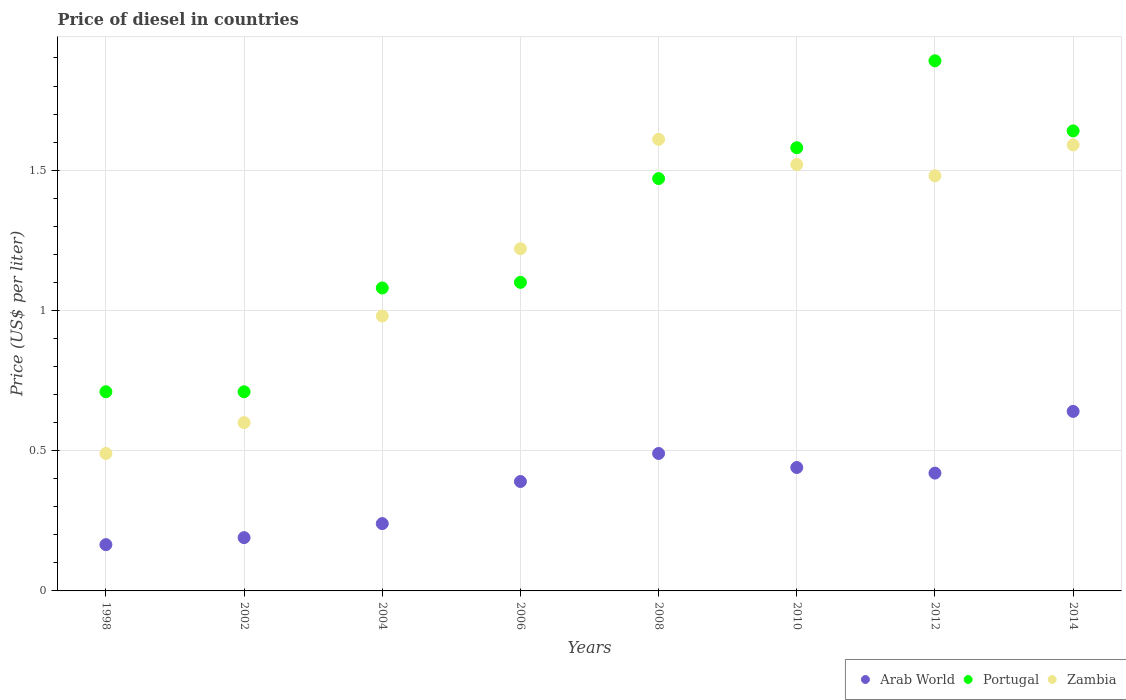What is the price of diesel in Zambia in 2012?
Your response must be concise. 1.48. Across all years, what is the maximum price of diesel in Zambia?
Offer a terse response. 1.61. Across all years, what is the minimum price of diesel in Portugal?
Provide a short and direct response. 0.71. What is the total price of diesel in Portugal in the graph?
Keep it short and to the point. 10.18. What is the difference between the price of diesel in Portugal in 2010 and that in 2014?
Provide a succinct answer. -0.06. What is the difference between the price of diesel in Portugal in 2014 and the price of diesel in Arab World in 2012?
Offer a very short reply. 1.22. What is the average price of diesel in Arab World per year?
Keep it short and to the point. 0.37. In the year 2006, what is the difference between the price of diesel in Arab World and price of diesel in Portugal?
Your response must be concise. -0.71. In how many years, is the price of diesel in Arab World greater than 0.1 US$?
Offer a terse response. 8. What is the ratio of the price of diesel in Portugal in 2012 to that in 2014?
Offer a terse response. 1.15. Is the difference between the price of diesel in Arab World in 2010 and 2012 greater than the difference between the price of diesel in Portugal in 2010 and 2012?
Offer a very short reply. Yes. What is the difference between the highest and the second highest price of diesel in Zambia?
Give a very brief answer. 0.02. What is the difference between the highest and the lowest price of diesel in Zambia?
Your response must be concise. 1.12. Does the price of diesel in Portugal monotonically increase over the years?
Your response must be concise. No. How many years are there in the graph?
Your response must be concise. 8. What is the difference between two consecutive major ticks on the Y-axis?
Ensure brevity in your answer.  0.5. Are the values on the major ticks of Y-axis written in scientific E-notation?
Make the answer very short. No. Does the graph contain grids?
Offer a terse response. Yes. Where does the legend appear in the graph?
Offer a terse response. Bottom right. How many legend labels are there?
Offer a very short reply. 3. How are the legend labels stacked?
Ensure brevity in your answer.  Horizontal. What is the title of the graph?
Provide a short and direct response. Price of diesel in countries. What is the label or title of the Y-axis?
Make the answer very short. Price (US$ per liter). What is the Price (US$ per liter) of Arab World in 1998?
Offer a very short reply. 0.17. What is the Price (US$ per liter) of Portugal in 1998?
Offer a very short reply. 0.71. What is the Price (US$ per liter) in Zambia in 1998?
Your answer should be very brief. 0.49. What is the Price (US$ per liter) in Arab World in 2002?
Your answer should be very brief. 0.19. What is the Price (US$ per liter) of Portugal in 2002?
Offer a very short reply. 0.71. What is the Price (US$ per liter) of Zambia in 2002?
Your answer should be compact. 0.6. What is the Price (US$ per liter) in Arab World in 2004?
Provide a short and direct response. 0.24. What is the Price (US$ per liter) in Portugal in 2004?
Your answer should be compact. 1.08. What is the Price (US$ per liter) in Zambia in 2004?
Provide a succinct answer. 0.98. What is the Price (US$ per liter) of Arab World in 2006?
Your answer should be compact. 0.39. What is the Price (US$ per liter) of Zambia in 2006?
Ensure brevity in your answer.  1.22. What is the Price (US$ per liter) in Arab World in 2008?
Your answer should be compact. 0.49. What is the Price (US$ per liter) in Portugal in 2008?
Ensure brevity in your answer.  1.47. What is the Price (US$ per liter) in Zambia in 2008?
Offer a very short reply. 1.61. What is the Price (US$ per liter) in Arab World in 2010?
Offer a terse response. 0.44. What is the Price (US$ per liter) of Portugal in 2010?
Make the answer very short. 1.58. What is the Price (US$ per liter) in Zambia in 2010?
Make the answer very short. 1.52. What is the Price (US$ per liter) in Arab World in 2012?
Ensure brevity in your answer.  0.42. What is the Price (US$ per liter) in Portugal in 2012?
Offer a terse response. 1.89. What is the Price (US$ per liter) in Zambia in 2012?
Your answer should be compact. 1.48. What is the Price (US$ per liter) in Arab World in 2014?
Make the answer very short. 0.64. What is the Price (US$ per liter) in Portugal in 2014?
Your response must be concise. 1.64. What is the Price (US$ per liter) in Zambia in 2014?
Make the answer very short. 1.59. Across all years, what is the maximum Price (US$ per liter) in Arab World?
Keep it short and to the point. 0.64. Across all years, what is the maximum Price (US$ per liter) of Portugal?
Offer a very short reply. 1.89. Across all years, what is the maximum Price (US$ per liter) in Zambia?
Your response must be concise. 1.61. Across all years, what is the minimum Price (US$ per liter) of Arab World?
Offer a terse response. 0.17. Across all years, what is the minimum Price (US$ per liter) in Portugal?
Your answer should be compact. 0.71. Across all years, what is the minimum Price (US$ per liter) in Zambia?
Provide a short and direct response. 0.49. What is the total Price (US$ per liter) of Arab World in the graph?
Ensure brevity in your answer.  2.98. What is the total Price (US$ per liter) of Portugal in the graph?
Provide a short and direct response. 10.18. What is the total Price (US$ per liter) in Zambia in the graph?
Ensure brevity in your answer.  9.49. What is the difference between the Price (US$ per liter) of Arab World in 1998 and that in 2002?
Your response must be concise. -0.03. What is the difference between the Price (US$ per liter) in Portugal in 1998 and that in 2002?
Keep it short and to the point. 0. What is the difference between the Price (US$ per liter) in Zambia in 1998 and that in 2002?
Your response must be concise. -0.11. What is the difference between the Price (US$ per liter) of Arab World in 1998 and that in 2004?
Your answer should be very brief. -0.07. What is the difference between the Price (US$ per liter) of Portugal in 1998 and that in 2004?
Keep it short and to the point. -0.37. What is the difference between the Price (US$ per liter) of Zambia in 1998 and that in 2004?
Your answer should be very brief. -0.49. What is the difference between the Price (US$ per liter) in Arab World in 1998 and that in 2006?
Keep it short and to the point. -0.23. What is the difference between the Price (US$ per liter) in Portugal in 1998 and that in 2006?
Make the answer very short. -0.39. What is the difference between the Price (US$ per liter) in Zambia in 1998 and that in 2006?
Provide a short and direct response. -0.73. What is the difference between the Price (US$ per liter) in Arab World in 1998 and that in 2008?
Provide a short and direct response. -0.33. What is the difference between the Price (US$ per liter) in Portugal in 1998 and that in 2008?
Make the answer very short. -0.76. What is the difference between the Price (US$ per liter) of Zambia in 1998 and that in 2008?
Offer a very short reply. -1.12. What is the difference between the Price (US$ per liter) of Arab World in 1998 and that in 2010?
Your response must be concise. -0.28. What is the difference between the Price (US$ per liter) in Portugal in 1998 and that in 2010?
Provide a succinct answer. -0.87. What is the difference between the Price (US$ per liter) of Zambia in 1998 and that in 2010?
Provide a short and direct response. -1.03. What is the difference between the Price (US$ per liter) in Arab World in 1998 and that in 2012?
Provide a succinct answer. -0.26. What is the difference between the Price (US$ per liter) of Portugal in 1998 and that in 2012?
Your answer should be compact. -1.18. What is the difference between the Price (US$ per liter) in Zambia in 1998 and that in 2012?
Provide a succinct answer. -0.99. What is the difference between the Price (US$ per liter) of Arab World in 1998 and that in 2014?
Your answer should be very brief. -0.47. What is the difference between the Price (US$ per liter) of Portugal in 1998 and that in 2014?
Your answer should be very brief. -0.93. What is the difference between the Price (US$ per liter) of Zambia in 1998 and that in 2014?
Provide a short and direct response. -1.1. What is the difference between the Price (US$ per liter) of Arab World in 2002 and that in 2004?
Keep it short and to the point. -0.05. What is the difference between the Price (US$ per liter) of Portugal in 2002 and that in 2004?
Make the answer very short. -0.37. What is the difference between the Price (US$ per liter) in Zambia in 2002 and that in 2004?
Offer a very short reply. -0.38. What is the difference between the Price (US$ per liter) of Arab World in 2002 and that in 2006?
Your answer should be compact. -0.2. What is the difference between the Price (US$ per liter) of Portugal in 2002 and that in 2006?
Your answer should be compact. -0.39. What is the difference between the Price (US$ per liter) of Zambia in 2002 and that in 2006?
Provide a short and direct response. -0.62. What is the difference between the Price (US$ per liter) of Portugal in 2002 and that in 2008?
Make the answer very short. -0.76. What is the difference between the Price (US$ per liter) of Zambia in 2002 and that in 2008?
Ensure brevity in your answer.  -1.01. What is the difference between the Price (US$ per liter) in Arab World in 2002 and that in 2010?
Your answer should be compact. -0.25. What is the difference between the Price (US$ per liter) of Portugal in 2002 and that in 2010?
Your response must be concise. -0.87. What is the difference between the Price (US$ per liter) in Zambia in 2002 and that in 2010?
Give a very brief answer. -0.92. What is the difference between the Price (US$ per liter) in Arab World in 2002 and that in 2012?
Ensure brevity in your answer.  -0.23. What is the difference between the Price (US$ per liter) in Portugal in 2002 and that in 2012?
Make the answer very short. -1.18. What is the difference between the Price (US$ per liter) of Zambia in 2002 and that in 2012?
Ensure brevity in your answer.  -0.88. What is the difference between the Price (US$ per liter) in Arab World in 2002 and that in 2014?
Offer a terse response. -0.45. What is the difference between the Price (US$ per liter) of Portugal in 2002 and that in 2014?
Ensure brevity in your answer.  -0.93. What is the difference between the Price (US$ per liter) in Zambia in 2002 and that in 2014?
Your answer should be compact. -0.99. What is the difference between the Price (US$ per liter) in Arab World in 2004 and that in 2006?
Ensure brevity in your answer.  -0.15. What is the difference between the Price (US$ per liter) of Portugal in 2004 and that in 2006?
Provide a succinct answer. -0.02. What is the difference between the Price (US$ per liter) of Zambia in 2004 and that in 2006?
Offer a terse response. -0.24. What is the difference between the Price (US$ per liter) in Arab World in 2004 and that in 2008?
Offer a terse response. -0.25. What is the difference between the Price (US$ per liter) in Portugal in 2004 and that in 2008?
Offer a very short reply. -0.39. What is the difference between the Price (US$ per liter) in Zambia in 2004 and that in 2008?
Give a very brief answer. -0.63. What is the difference between the Price (US$ per liter) in Portugal in 2004 and that in 2010?
Give a very brief answer. -0.5. What is the difference between the Price (US$ per liter) of Zambia in 2004 and that in 2010?
Your answer should be compact. -0.54. What is the difference between the Price (US$ per liter) in Arab World in 2004 and that in 2012?
Provide a short and direct response. -0.18. What is the difference between the Price (US$ per liter) of Portugal in 2004 and that in 2012?
Offer a terse response. -0.81. What is the difference between the Price (US$ per liter) of Portugal in 2004 and that in 2014?
Your response must be concise. -0.56. What is the difference between the Price (US$ per liter) of Zambia in 2004 and that in 2014?
Make the answer very short. -0.61. What is the difference between the Price (US$ per liter) in Arab World in 2006 and that in 2008?
Offer a very short reply. -0.1. What is the difference between the Price (US$ per liter) of Portugal in 2006 and that in 2008?
Offer a very short reply. -0.37. What is the difference between the Price (US$ per liter) in Zambia in 2006 and that in 2008?
Keep it short and to the point. -0.39. What is the difference between the Price (US$ per liter) of Arab World in 2006 and that in 2010?
Your answer should be very brief. -0.05. What is the difference between the Price (US$ per liter) of Portugal in 2006 and that in 2010?
Your answer should be very brief. -0.48. What is the difference between the Price (US$ per liter) of Arab World in 2006 and that in 2012?
Keep it short and to the point. -0.03. What is the difference between the Price (US$ per liter) of Portugal in 2006 and that in 2012?
Give a very brief answer. -0.79. What is the difference between the Price (US$ per liter) of Zambia in 2006 and that in 2012?
Ensure brevity in your answer.  -0.26. What is the difference between the Price (US$ per liter) of Arab World in 2006 and that in 2014?
Provide a short and direct response. -0.25. What is the difference between the Price (US$ per liter) in Portugal in 2006 and that in 2014?
Offer a terse response. -0.54. What is the difference between the Price (US$ per liter) of Zambia in 2006 and that in 2014?
Ensure brevity in your answer.  -0.37. What is the difference between the Price (US$ per liter) of Portugal in 2008 and that in 2010?
Give a very brief answer. -0.11. What is the difference between the Price (US$ per liter) of Zambia in 2008 and that in 2010?
Your answer should be very brief. 0.09. What is the difference between the Price (US$ per liter) of Arab World in 2008 and that in 2012?
Offer a terse response. 0.07. What is the difference between the Price (US$ per liter) of Portugal in 2008 and that in 2012?
Give a very brief answer. -0.42. What is the difference between the Price (US$ per liter) in Zambia in 2008 and that in 2012?
Your answer should be very brief. 0.13. What is the difference between the Price (US$ per liter) in Portugal in 2008 and that in 2014?
Provide a succinct answer. -0.17. What is the difference between the Price (US$ per liter) of Zambia in 2008 and that in 2014?
Give a very brief answer. 0.02. What is the difference between the Price (US$ per liter) of Arab World in 2010 and that in 2012?
Offer a very short reply. 0.02. What is the difference between the Price (US$ per liter) in Portugal in 2010 and that in 2012?
Your answer should be compact. -0.31. What is the difference between the Price (US$ per liter) of Zambia in 2010 and that in 2012?
Offer a very short reply. 0.04. What is the difference between the Price (US$ per liter) in Arab World in 2010 and that in 2014?
Your answer should be very brief. -0.2. What is the difference between the Price (US$ per liter) in Portugal in 2010 and that in 2014?
Keep it short and to the point. -0.06. What is the difference between the Price (US$ per liter) of Zambia in 2010 and that in 2014?
Give a very brief answer. -0.07. What is the difference between the Price (US$ per liter) of Arab World in 2012 and that in 2014?
Make the answer very short. -0.22. What is the difference between the Price (US$ per liter) in Portugal in 2012 and that in 2014?
Ensure brevity in your answer.  0.25. What is the difference between the Price (US$ per liter) of Zambia in 2012 and that in 2014?
Ensure brevity in your answer.  -0.11. What is the difference between the Price (US$ per liter) in Arab World in 1998 and the Price (US$ per liter) in Portugal in 2002?
Make the answer very short. -0.55. What is the difference between the Price (US$ per liter) in Arab World in 1998 and the Price (US$ per liter) in Zambia in 2002?
Offer a very short reply. -0.43. What is the difference between the Price (US$ per liter) of Portugal in 1998 and the Price (US$ per liter) of Zambia in 2002?
Offer a terse response. 0.11. What is the difference between the Price (US$ per liter) in Arab World in 1998 and the Price (US$ per liter) in Portugal in 2004?
Offer a very short reply. -0.92. What is the difference between the Price (US$ per liter) in Arab World in 1998 and the Price (US$ per liter) in Zambia in 2004?
Provide a succinct answer. -0.81. What is the difference between the Price (US$ per liter) of Portugal in 1998 and the Price (US$ per liter) of Zambia in 2004?
Keep it short and to the point. -0.27. What is the difference between the Price (US$ per liter) of Arab World in 1998 and the Price (US$ per liter) of Portugal in 2006?
Offer a terse response. -0.94. What is the difference between the Price (US$ per liter) in Arab World in 1998 and the Price (US$ per liter) in Zambia in 2006?
Give a very brief answer. -1.05. What is the difference between the Price (US$ per liter) of Portugal in 1998 and the Price (US$ per liter) of Zambia in 2006?
Provide a short and direct response. -0.51. What is the difference between the Price (US$ per liter) of Arab World in 1998 and the Price (US$ per liter) of Portugal in 2008?
Keep it short and to the point. -1.3. What is the difference between the Price (US$ per liter) in Arab World in 1998 and the Price (US$ per liter) in Zambia in 2008?
Your answer should be very brief. -1.45. What is the difference between the Price (US$ per liter) in Portugal in 1998 and the Price (US$ per liter) in Zambia in 2008?
Offer a terse response. -0.9. What is the difference between the Price (US$ per liter) in Arab World in 1998 and the Price (US$ per liter) in Portugal in 2010?
Your response must be concise. -1.42. What is the difference between the Price (US$ per liter) of Arab World in 1998 and the Price (US$ per liter) of Zambia in 2010?
Offer a very short reply. -1.35. What is the difference between the Price (US$ per liter) in Portugal in 1998 and the Price (US$ per liter) in Zambia in 2010?
Give a very brief answer. -0.81. What is the difference between the Price (US$ per liter) of Arab World in 1998 and the Price (US$ per liter) of Portugal in 2012?
Ensure brevity in your answer.  -1.73. What is the difference between the Price (US$ per liter) in Arab World in 1998 and the Price (US$ per liter) in Zambia in 2012?
Provide a short and direct response. -1.31. What is the difference between the Price (US$ per liter) in Portugal in 1998 and the Price (US$ per liter) in Zambia in 2012?
Offer a terse response. -0.77. What is the difference between the Price (US$ per liter) in Arab World in 1998 and the Price (US$ per liter) in Portugal in 2014?
Your answer should be compact. -1.48. What is the difference between the Price (US$ per liter) in Arab World in 1998 and the Price (US$ per liter) in Zambia in 2014?
Offer a very short reply. -1.43. What is the difference between the Price (US$ per liter) of Portugal in 1998 and the Price (US$ per liter) of Zambia in 2014?
Make the answer very short. -0.88. What is the difference between the Price (US$ per liter) of Arab World in 2002 and the Price (US$ per liter) of Portugal in 2004?
Provide a succinct answer. -0.89. What is the difference between the Price (US$ per liter) in Arab World in 2002 and the Price (US$ per liter) in Zambia in 2004?
Give a very brief answer. -0.79. What is the difference between the Price (US$ per liter) of Portugal in 2002 and the Price (US$ per liter) of Zambia in 2004?
Make the answer very short. -0.27. What is the difference between the Price (US$ per liter) in Arab World in 2002 and the Price (US$ per liter) in Portugal in 2006?
Offer a terse response. -0.91. What is the difference between the Price (US$ per liter) of Arab World in 2002 and the Price (US$ per liter) of Zambia in 2006?
Keep it short and to the point. -1.03. What is the difference between the Price (US$ per liter) of Portugal in 2002 and the Price (US$ per liter) of Zambia in 2006?
Your answer should be compact. -0.51. What is the difference between the Price (US$ per liter) of Arab World in 2002 and the Price (US$ per liter) of Portugal in 2008?
Ensure brevity in your answer.  -1.28. What is the difference between the Price (US$ per liter) in Arab World in 2002 and the Price (US$ per liter) in Zambia in 2008?
Provide a succinct answer. -1.42. What is the difference between the Price (US$ per liter) in Portugal in 2002 and the Price (US$ per liter) in Zambia in 2008?
Give a very brief answer. -0.9. What is the difference between the Price (US$ per liter) in Arab World in 2002 and the Price (US$ per liter) in Portugal in 2010?
Your answer should be very brief. -1.39. What is the difference between the Price (US$ per liter) of Arab World in 2002 and the Price (US$ per liter) of Zambia in 2010?
Your answer should be compact. -1.33. What is the difference between the Price (US$ per liter) in Portugal in 2002 and the Price (US$ per liter) in Zambia in 2010?
Your answer should be compact. -0.81. What is the difference between the Price (US$ per liter) in Arab World in 2002 and the Price (US$ per liter) in Zambia in 2012?
Provide a short and direct response. -1.29. What is the difference between the Price (US$ per liter) in Portugal in 2002 and the Price (US$ per liter) in Zambia in 2012?
Keep it short and to the point. -0.77. What is the difference between the Price (US$ per liter) in Arab World in 2002 and the Price (US$ per liter) in Portugal in 2014?
Give a very brief answer. -1.45. What is the difference between the Price (US$ per liter) of Arab World in 2002 and the Price (US$ per liter) of Zambia in 2014?
Provide a succinct answer. -1.4. What is the difference between the Price (US$ per liter) of Portugal in 2002 and the Price (US$ per liter) of Zambia in 2014?
Your answer should be very brief. -0.88. What is the difference between the Price (US$ per liter) in Arab World in 2004 and the Price (US$ per liter) in Portugal in 2006?
Your answer should be compact. -0.86. What is the difference between the Price (US$ per liter) in Arab World in 2004 and the Price (US$ per liter) in Zambia in 2006?
Ensure brevity in your answer.  -0.98. What is the difference between the Price (US$ per liter) in Portugal in 2004 and the Price (US$ per liter) in Zambia in 2006?
Your response must be concise. -0.14. What is the difference between the Price (US$ per liter) of Arab World in 2004 and the Price (US$ per liter) of Portugal in 2008?
Keep it short and to the point. -1.23. What is the difference between the Price (US$ per liter) of Arab World in 2004 and the Price (US$ per liter) of Zambia in 2008?
Your answer should be compact. -1.37. What is the difference between the Price (US$ per liter) in Portugal in 2004 and the Price (US$ per liter) in Zambia in 2008?
Make the answer very short. -0.53. What is the difference between the Price (US$ per liter) in Arab World in 2004 and the Price (US$ per liter) in Portugal in 2010?
Offer a very short reply. -1.34. What is the difference between the Price (US$ per liter) in Arab World in 2004 and the Price (US$ per liter) in Zambia in 2010?
Your response must be concise. -1.28. What is the difference between the Price (US$ per liter) of Portugal in 2004 and the Price (US$ per liter) of Zambia in 2010?
Your answer should be compact. -0.44. What is the difference between the Price (US$ per liter) of Arab World in 2004 and the Price (US$ per liter) of Portugal in 2012?
Keep it short and to the point. -1.65. What is the difference between the Price (US$ per liter) in Arab World in 2004 and the Price (US$ per liter) in Zambia in 2012?
Your answer should be very brief. -1.24. What is the difference between the Price (US$ per liter) in Arab World in 2004 and the Price (US$ per liter) in Portugal in 2014?
Provide a short and direct response. -1.4. What is the difference between the Price (US$ per liter) of Arab World in 2004 and the Price (US$ per liter) of Zambia in 2014?
Your answer should be compact. -1.35. What is the difference between the Price (US$ per liter) in Portugal in 2004 and the Price (US$ per liter) in Zambia in 2014?
Your response must be concise. -0.51. What is the difference between the Price (US$ per liter) of Arab World in 2006 and the Price (US$ per liter) of Portugal in 2008?
Keep it short and to the point. -1.08. What is the difference between the Price (US$ per liter) in Arab World in 2006 and the Price (US$ per liter) in Zambia in 2008?
Your answer should be very brief. -1.22. What is the difference between the Price (US$ per liter) of Portugal in 2006 and the Price (US$ per liter) of Zambia in 2008?
Ensure brevity in your answer.  -0.51. What is the difference between the Price (US$ per liter) of Arab World in 2006 and the Price (US$ per liter) of Portugal in 2010?
Give a very brief answer. -1.19. What is the difference between the Price (US$ per liter) of Arab World in 2006 and the Price (US$ per liter) of Zambia in 2010?
Offer a very short reply. -1.13. What is the difference between the Price (US$ per liter) in Portugal in 2006 and the Price (US$ per liter) in Zambia in 2010?
Your response must be concise. -0.42. What is the difference between the Price (US$ per liter) of Arab World in 2006 and the Price (US$ per liter) of Portugal in 2012?
Your answer should be very brief. -1.5. What is the difference between the Price (US$ per liter) in Arab World in 2006 and the Price (US$ per liter) in Zambia in 2012?
Keep it short and to the point. -1.09. What is the difference between the Price (US$ per liter) of Portugal in 2006 and the Price (US$ per liter) of Zambia in 2012?
Offer a very short reply. -0.38. What is the difference between the Price (US$ per liter) of Arab World in 2006 and the Price (US$ per liter) of Portugal in 2014?
Provide a short and direct response. -1.25. What is the difference between the Price (US$ per liter) in Arab World in 2006 and the Price (US$ per liter) in Zambia in 2014?
Your answer should be very brief. -1.2. What is the difference between the Price (US$ per liter) of Portugal in 2006 and the Price (US$ per liter) of Zambia in 2014?
Your answer should be compact. -0.49. What is the difference between the Price (US$ per liter) of Arab World in 2008 and the Price (US$ per liter) of Portugal in 2010?
Keep it short and to the point. -1.09. What is the difference between the Price (US$ per liter) in Arab World in 2008 and the Price (US$ per liter) in Zambia in 2010?
Make the answer very short. -1.03. What is the difference between the Price (US$ per liter) in Arab World in 2008 and the Price (US$ per liter) in Zambia in 2012?
Ensure brevity in your answer.  -0.99. What is the difference between the Price (US$ per liter) in Portugal in 2008 and the Price (US$ per liter) in Zambia in 2012?
Ensure brevity in your answer.  -0.01. What is the difference between the Price (US$ per liter) of Arab World in 2008 and the Price (US$ per liter) of Portugal in 2014?
Make the answer very short. -1.15. What is the difference between the Price (US$ per liter) in Arab World in 2008 and the Price (US$ per liter) in Zambia in 2014?
Your answer should be very brief. -1.1. What is the difference between the Price (US$ per liter) of Portugal in 2008 and the Price (US$ per liter) of Zambia in 2014?
Your answer should be compact. -0.12. What is the difference between the Price (US$ per liter) of Arab World in 2010 and the Price (US$ per liter) of Portugal in 2012?
Provide a succinct answer. -1.45. What is the difference between the Price (US$ per liter) of Arab World in 2010 and the Price (US$ per liter) of Zambia in 2012?
Offer a very short reply. -1.04. What is the difference between the Price (US$ per liter) in Arab World in 2010 and the Price (US$ per liter) in Zambia in 2014?
Ensure brevity in your answer.  -1.15. What is the difference between the Price (US$ per liter) in Portugal in 2010 and the Price (US$ per liter) in Zambia in 2014?
Your answer should be very brief. -0.01. What is the difference between the Price (US$ per liter) in Arab World in 2012 and the Price (US$ per liter) in Portugal in 2014?
Ensure brevity in your answer.  -1.22. What is the difference between the Price (US$ per liter) of Arab World in 2012 and the Price (US$ per liter) of Zambia in 2014?
Keep it short and to the point. -1.17. What is the difference between the Price (US$ per liter) in Portugal in 2012 and the Price (US$ per liter) in Zambia in 2014?
Your response must be concise. 0.3. What is the average Price (US$ per liter) of Arab World per year?
Give a very brief answer. 0.37. What is the average Price (US$ per liter) of Portugal per year?
Your answer should be compact. 1.27. What is the average Price (US$ per liter) in Zambia per year?
Your response must be concise. 1.19. In the year 1998, what is the difference between the Price (US$ per liter) in Arab World and Price (US$ per liter) in Portugal?
Your answer should be very brief. -0.55. In the year 1998, what is the difference between the Price (US$ per liter) in Arab World and Price (US$ per liter) in Zambia?
Provide a short and direct response. -0.33. In the year 1998, what is the difference between the Price (US$ per liter) in Portugal and Price (US$ per liter) in Zambia?
Offer a very short reply. 0.22. In the year 2002, what is the difference between the Price (US$ per liter) of Arab World and Price (US$ per liter) of Portugal?
Ensure brevity in your answer.  -0.52. In the year 2002, what is the difference between the Price (US$ per liter) of Arab World and Price (US$ per liter) of Zambia?
Provide a succinct answer. -0.41. In the year 2002, what is the difference between the Price (US$ per liter) in Portugal and Price (US$ per liter) in Zambia?
Your answer should be very brief. 0.11. In the year 2004, what is the difference between the Price (US$ per liter) of Arab World and Price (US$ per liter) of Portugal?
Offer a very short reply. -0.84. In the year 2004, what is the difference between the Price (US$ per liter) in Arab World and Price (US$ per liter) in Zambia?
Your answer should be very brief. -0.74. In the year 2006, what is the difference between the Price (US$ per liter) in Arab World and Price (US$ per liter) in Portugal?
Keep it short and to the point. -0.71. In the year 2006, what is the difference between the Price (US$ per liter) of Arab World and Price (US$ per liter) of Zambia?
Give a very brief answer. -0.83. In the year 2006, what is the difference between the Price (US$ per liter) in Portugal and Price (US$ per liter) in Zambia?
Keep it short and to the point. -0.12. In the year 2008, what is the difference between the Price (US$ per liter) in Arab World and Price (US$ per liter) in Portugal?
Offer a terse response. -0.98. In the year 2008, what is the difference between the Price (US$ per liter) of Arab World and Price (US$ per liter) of Zambia?
Ensure brevity in your answer.  -1.12. In the year 2008, what is the difference between the Price (US$ per liter) in Portugal and Price (US$ per liter) in Zambia?
Ensure brevity in your answer.  -0.14. In the year 2010, what is the difference between the Price (US$ per liter) in Arab World and Price (US$ per liter) in Portugal?
Your answer should be very brief. -1.14. In the year 2010, what is the difference between the Price (US$ per liter) in Arab World and Price (US$ per liter) in Zambia?
Offer a very short reply. -1.08. In the year 2010, what is the difference between the Price (US$ per liter) in Portugal and Price (US$ per liter) in Zambia?
Give a very brief answer. 0.06. In the year 2012, what is the difference between the Price (US$ per liter) of Arab World and Price (US$ per liter) of Portugal?
Offer a very short reply. -1.47. In the year 2012, what is the difference between the Price (US$ per liter) in Arab World and Price (US$ per liter) in Zambia?
Give a very brief answer. -1.06. In the year 2012, what is the difference between the Price (US$ per liter) of Portugal and Price (US$ per liter) of Zambia?
Keep it short and to the point. 0.41. In the year 2014, what is the difference between the Price (US$ per liter) of Arab World and Price (US$ per liter) of Zambia?
Your answer should be very brief. -0.95. What is the ratio of the Price (US$ per liter) in Arab World in 1998 to that in 2002?
Give a very brief answer. 0.87. What is the ratio of the Price (US$ per liter) of Portugal in 1998 to that in 2002?
Offer a very short reply. 1. What is the ratio of the Price (US$ per liter) of Zambia in 1998 to that in 2002?
Your response must be concise. 0.82. What is the ratio of the Price (US$ per liter) in Arab World in 1998 to that in 2004?
Your answer should be compact. 0.69. What is the ratio of the Price (US$ per liter) of Portugal in 1998 to that in 2004?
Make the answer very short. 0.66. What is the ratio of the Price (US$ per liter) of Arab World in 1998 to that in 2006?
Your answer should be very brief. 0.42. What is the ratio of the Price (US$ per liter) of Portugal in 1998 to that in 2006?
Keep it short and to the point. 0.65. What is the ratio of the Price (US$ per liter) in Zambia in 1998 to that in 2006?
Make the answer very short. 0.4. What is the ratio of the Price (US$ per liter) of Arab World in 1998 to that in 2008?
Provide a short and direct response. 0.34. What is the ratio of the Price (US$ per liter) in Portugal in 1998 to that in 2008?
Offer a terse response. 0.48. What is the ratio of the Price (US$ per liter) of Zambia in 1998 to that in 2008?
Provide a succinct answer. 0.3. What is the ratio of the Price (US$ per liter) of Portugal in 1998 to that in 2010?
Provide a short and direct response. 0.45. What is the ratio of the Price (US$ per liter) of Zambia in 1998 to that in 2010?
Offer a terse response. 0.32. What is the ratio of the Price (US$ per liter) in Arab World in 1998 to that in 2012?
Offer a terse response. 0.39. What is the ratio of the Price (US$ per liter) in Portugal in 1998 to that in 2012?
Make the answer very short. 0.38. What is the ratio of the Price (US$ per liter) in Zambia in 1998 to that in 2012?
Offer a terse response. 0.33. What is the ratio of the Price (US$ per liter) of Arab World in 1998 to that in 2014?
Make the answer very short. 0.26. What is the ratio of the Price (US$ per liter) of Portugal in 1998 to that in 2014?
Make the answer very short. 0.43. What is the ratio of the Price (US$ per liter) of Zambia in 1998 to that in 2014?
Provide a succinct answer. 0.31. What is the ratio of the Price (US$ per liter) of Arab World in 2002 to that in 2004?
Give a very brief answer. 0.79. What is the ratio of the Price (US$ per liter) in Portugal in 2002 to that in 2004?
Keep it short and to the point. 0.66. What is the ratio of the Price (US$ per liter) of Zambia in 2002 to that in 2004?
Provide a short and direct response. 0.61. What is the ratio of the Price (US$ per liter) of Arab World in 2002 to that in 2006?
Ensure brevity in your answer.  0.49. What is the ratio of the Price (US$ per liter) in Portugal in 2002 to that in 2006?
Give a very brief answer. 0.65. What is the ratio of the Price (US$ per liter) in Zambia in 2002 to that in 2006?
Provide a short and direct response. 0.49. What is the ratio of the Price (US$ per liter) in Arab World in 2002 to that in 2008?
Ensure brevity in your answer.  0.39. What is the ratio of the Price (US$ per liter) of Portugal in 2002 to that in 2008?
Keep it short and to the point. 0.48. What is the ratio of the Price (US$ per liter) of Zambia in 2002 to that in 2008?
Ensure brevity in your answer.  0.37. What is the ratio of the Price (US$ per liter) of Arab World in 2002 to that in 2010?
Your answer should be very brief. 0.43. What is the ratio of the Price (US$ per liter) in Portugal in 2002 to that in 2010?
Give a very brief answer. 0.45. What is the ratio of the Price (US$ per liter) of Zambia in 2002 to that in 2010?
Your answer should be compact. 0.39. What is the ratio of the Price (US$ per liter) of Arab World in 2002 to that in 2012?
Provide a succinct answer. 0.45. What is the ratio of the Price (US$ per liter) of Portugal in 2002 to that in 2012?
Your answer should be compact. 0.38. What is the ratio of the Price (US$ per liter) of Zambia in 2002 to that in 2012?
Your answer should be very brief. 0.41. What is the ratio of the Price (US$ per liter) of Arab World in 2002 to that in 2014?
Your answer should be very brief. 0.3. What is the ratio of the Price (US$ per liter) of Portugal in 2002 to that in 2014?
Provide a succinct answer. 0.43. What is the ratio of the Price (US$ per liter) in Zambia in 2002 to that in 2014?
Offer a very short reply. 0.38. What is the ratio of the Price (US$ per liter) in Arab World in 2004 to that in 2006?
Give a very brief answer. 0.62. What is the ratio of the Price (US$ per liter) in Portugal in 2004 to that in 2006?
Make the answer very short. 0.98. What is the ratio of the Price (US$ per liter) in Zambia in 2004 to that in 2006?
Offer a very short reply. 0.8. What is the ratio of the Price (US$ per liter) in Arab World in 2004 to that in 2008?
Your answer should be compact. 0.49. What is the ratio of the Price (US$ per liter) in Portugal in 2004 to that in 2008?
Your answer should be compact. 0.73. What is the ratio of the Price (US$ per liter) of Zambia in 2004 to that in 2008?
Your response must be concise. 0.61. What is the ratio of the Price (US$ per liter) in Arab World in 2004 to that in 2010?
Your answer should be compact. 0.55. What is the ratio of the Price (US$ per liter) in Portugal in 2004 to that in 2010?
Offer a terse response. 0.68. What is the ratio of the Price (US$ per liter) of Zambia in 2004 to that in 2010?
Keep it short and to the point. 0.64. What is the ratio of the Price (US$ per liter) in Arab World in 2004 to that in 2012?
Keep it short and to the point. 0.57. What is the ratio of the Price (US$ per liter) in Portugal in 2004 to that in 2012?
Provide a short and direct response. 0.57. What is the ratio of the Price (US$ per liter) of Zambia in 2004 to that in 2012?
Offer a terse response. 0.66. What is the ratio of the Price (US$ per liter) of Portugal in 2004 to that in 2014?
Offer a very short reply. 0.66. What is the ratio of the Price (US$ per liter) in Zambia in 2004 to that in 2014?
Keep it short and to the point. 0.62. What is the ratio of the Price (US$ per liter) in Arab World in 2006 to that in 2008?
Ensure brevity in your answer.  0.8. What is the ratio of the Price (US$ per liter) of Portugal in 2006 to that in 2008?
Keep it short and to the point. 0.75. What is the ratio of the Price (US$ per liter) in Zambia in 2006 to that in 2008?
Make the answer very short. 0.76. What is the ratio of the Price (US$ per liter) in Arab World in 2006 to that in 2010?
Your answer should be compact. 0.89. What is the ratio of the Price (US$ per liter) in Portugal in 2006 to that in 2010?
Offer a very short reply. 0.7. What is the ratio of the Price (US$ per liter) in Zambia in 2006 to that in 2010?
Keep it short and to the point. 0.8. What is the ratio of the Price (US$ per liter) of Arab World in 2006 to that in 2012?
Your answer should be compact. 0.93. What is the ratio of the Price (US$ per liter) of Portugal in 2006 to that in 2012?
Keep it short and to the point. 0.58. What is the ratio of the Price (US$ per liter) of Zambia in 2006 to that in 2012?
Offer a very short reply. 0.82. What is the ratio of the Price (US$ per liter) of Arab World in 2006 to that in 2014?
Provide a short and direct response. 0.61. What is the ratio of the Price (US$ per liter) in Portugal in 2006 to that in 2014?
Keep it short and to the point. 0.67. What is the ratio of the Price (US$ per liter) in Zambia in 2006 to that in 2014?
Your answer should be very brief. 0.77. What is the ratio of the Price (US$ per liter) in Arab World in 2008 to that in 2010?
Your answer should be very brief. 1.11. What is the ratio of the Price (US$ per liter) of Portugal in 2008 to that in 2010?
Make the answer very short. 0.93. What is the ratio of the Price (US$ per liter) of Zambia in 2008 to that in 2010?
Offer a terse response. 1.06. What is the ratio of the Price (US$ per liter) of Portugal in 2008 to that in 2012?
Your answer should be very brief. 0.78. What is the ratio of the Price (US$ per liter) in Zambia in 2008 to that in 2012?
Ensure brevity in your answer.  1.09. What is the ratio of the Price (US$ per liter) in Arab World in 2008 to that in 2014?
Keep it short and to the point. 0.77. What is the ratio of the Price (US$ per liter) in Portugal in 2008 to that in 2014?
Offer a terse response. 0.9. What is the ratio of the Price (US$ per liter) in Zambia in 2008 to that in 2014?
Give a very brief answer. 1.01. What is the ratio of the Price (US$ per liter) in Arab World in 2010 to that in 2012?
Your answer should be compact. 1.05. What is the ratio of the Price (US$ per liter) in Portugal in 2010 to that in 2012?
Offer a terse response. 0.84. What is the ratio of the Price (US$ per liter) in Arab World in 2010 to that in 2014?
Offer a very short reply. 0.69. What is the ratio of the Price (US$ per liter) of Portugal in 2010 to that in 2014?
Give a very brief answer. 0.96. What is the ratio of the Price (US$ per liter) in Zambia in 2010 to that in 2014?
Offer a very short reply. 0.96. What is the ratio of the Price (US$ per liter) in Arab World in 2012 to that in 2014?
Provide a succinct answer. 0.66. What is the ratio of the Price (US$ per liter) in Portugal in 2012 to that in 2014?
Provide a short and direct response. 1.15. What is the ratio of the Price (US$ per liter) in Zambia in 2012 to that in 2014?
Your answer should be compact. 0.93. What is the difference between the highest and the second highest Price (US$ per liter) in Portugal?
Give a very brief answer. 0.25. What is the difference between the highest and the second highest Price (US$ per liter) of Zambia?
Make the answer very short. 0.02. What is the difference between the highest and the lowest Price (US$ per liter) of Arab World?
Make the answer very short. 0.47. What is the difference between the highest and the lowest Price (US$ per liter) in Portugal?
Make the answer very short. 1.18. What is the difference between the highest and the lowest Price (US$ per liter) of Zambia?
Give a very brief answer. 1.12. 